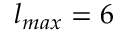Convert formula to latex. <formula><loc_0><loc_0><loc_500><loc_500>l _ { \max } = 6</formula> 